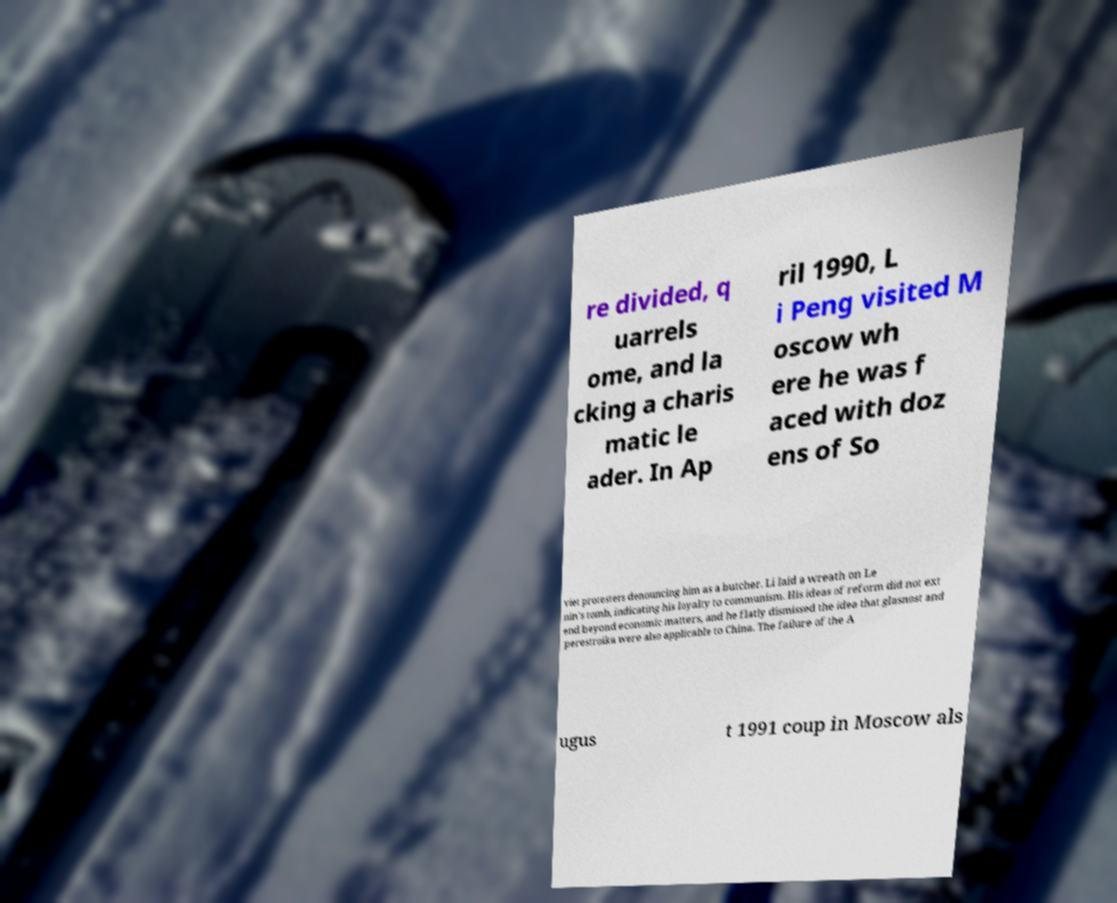Could you extract and type out the text from this image? re divided, q uarrels ome, and la cking a charis matic le ader. In Ap ril 1990, L i Peng visited M oscow wh ere he was f aced with doz ens of So viet protesters denouncing him as a butcher. Li laid a wreath on Le nin's tomb, indicating his loyalty to communism. His ideas of reform did not ext end beyond economic matters, and he flatly dismissed the idea that glasnost and perestroika were also applicable to China. The failure of the A ugus t 1991 coup in Moscow als 